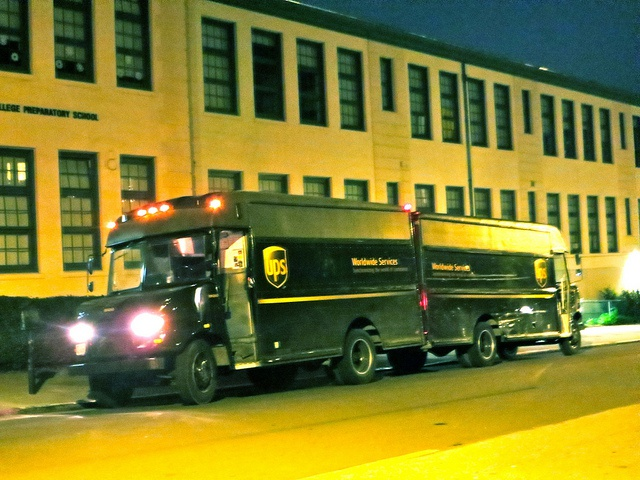Describe the objects in this image and their specific colors. I can see a truck in darkgreen and black tones in this image. 